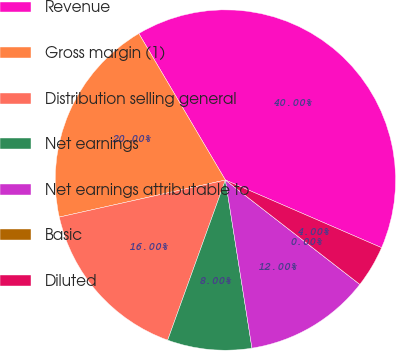<chart> <loc_0><loc_0><loc_500><loc_500><pie_chart><fcel>Revenue<fcel>Gross margin (1)<fcel>Distribution selling general<fcel>Net earnings<fcel>Net earnings attributable to<fcel>Basic<fcel>Diluted<nl><fcel>40.0%<fcel>20.0%<fcel>16.0%<fcel>8.0%<fcel>12.0%<fcel>0.0%<fcel>4.0%<nl></chart> 